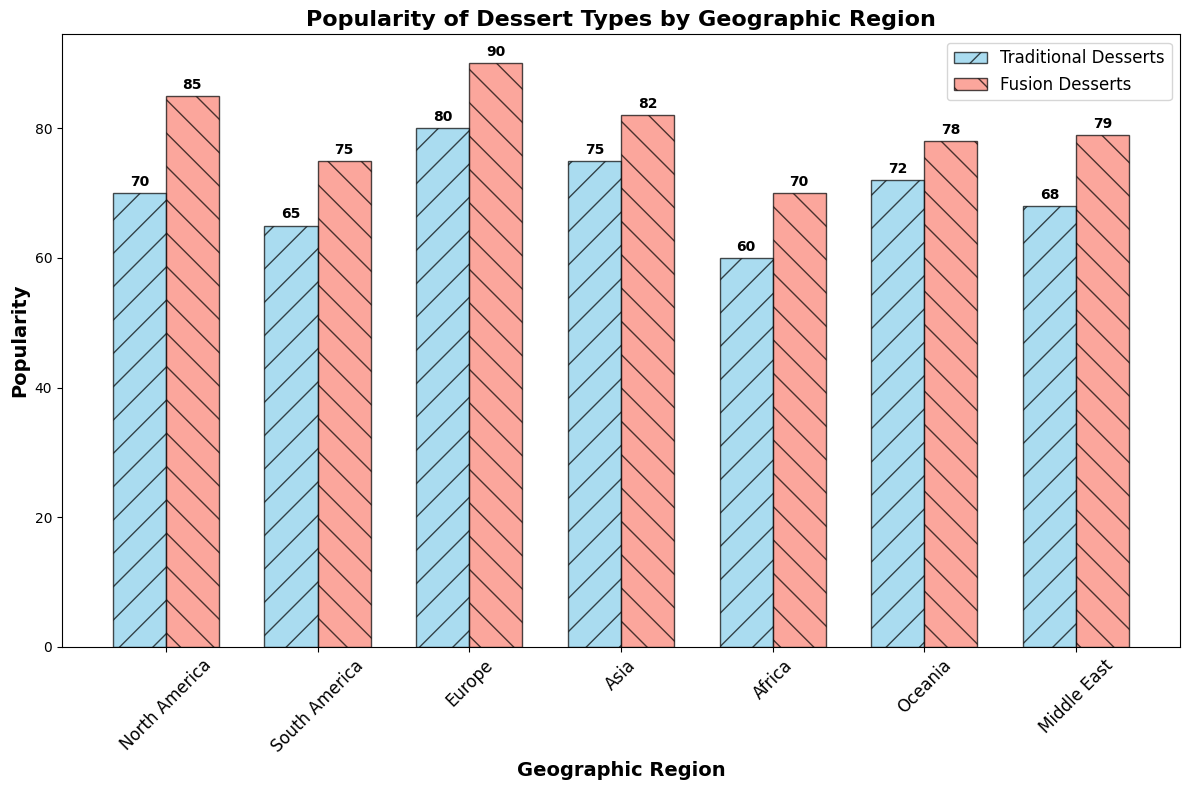Which region has the highest popularity for Fusion Desserts? First, identify the bars representing Fusion Desserts. The tallest bar among them corresponds to Europe. Hence, Europe has the highest popularity for Fusion Desserts.
Answer: Europe Which region has the lowest popularity for Traditional Desserts? Identify the bars for Traditional Desserts. The shortest one is for Africa. Thus, Africa has the lowest popularity for Traditional Desserts.
Answer: Africa What's the difference in popularity of Fusion Desserts between Europe and North America? Fusion Desserts in Europe have a popularity of 90, while in North America, it's 85. The difference is calculated as 90 - 85 = 5.
Answer: 5 How many regions have a popularity of Traditional Desserts above 70? Look at the bars representing Traditional Desserts and check their values. North America (70), Europe (80), Asia (75), and Oceania (72) are above 70. That makes 4 regions.
Answer: 4 Compare the popularity of Fusion Desserts and Traditional Desserts in Asia. Which one is more popular? The bars for Asia show that Fusion Desserts have a popularity of 82, and Traditional Desserts have 75. Fusion Desserts are more popular.
Answer: Fusion Desserts What is the total popularity of Fusion Desserts across all regions? Sum up the popularity values for Fusion Desserts across all regions: 85 (North America) + 75 (South America) + 90 (Europe) + 82 (Asia) + 70 (Africa) + 78 (Oceania) + 79 (Middle East) = 559.
Answer: 559 Which region shows exactly the same popularity for both Traditional Desserts and Fusion Desserts? Check each region to see if any has equal values for both dessert types. No region has the same popularity for both dessert types.
Answer: None What is the average popularity of Traditional Desserts across all regions? Sum up the Traditional Desserts popularity values: 70 + 65 + 80 + 75 + 60 + 72 + 68 = 490. Then, divide by the number of regions, which is 7. The average is 490 / 7 ≈ 70.
Answer: 70 How much more popular are Fusion Desserts than Traditional Desserts in the Middle East? In the Middle East, Fusion Desserts have a popularity of 79 and Traditional Desserts have 68. Subtract to find the difference: 79 - 68 = 11.
Answer: 11 Which dessert type, Traditional or Fusion, has greater overall popularity in Oceania? The bars for Oceania show that Traditional Desserts have a popularity of 72, and Fusion Desserts have 78. Fusion Desserts are more popular.
Answer: Fusion Desserts 